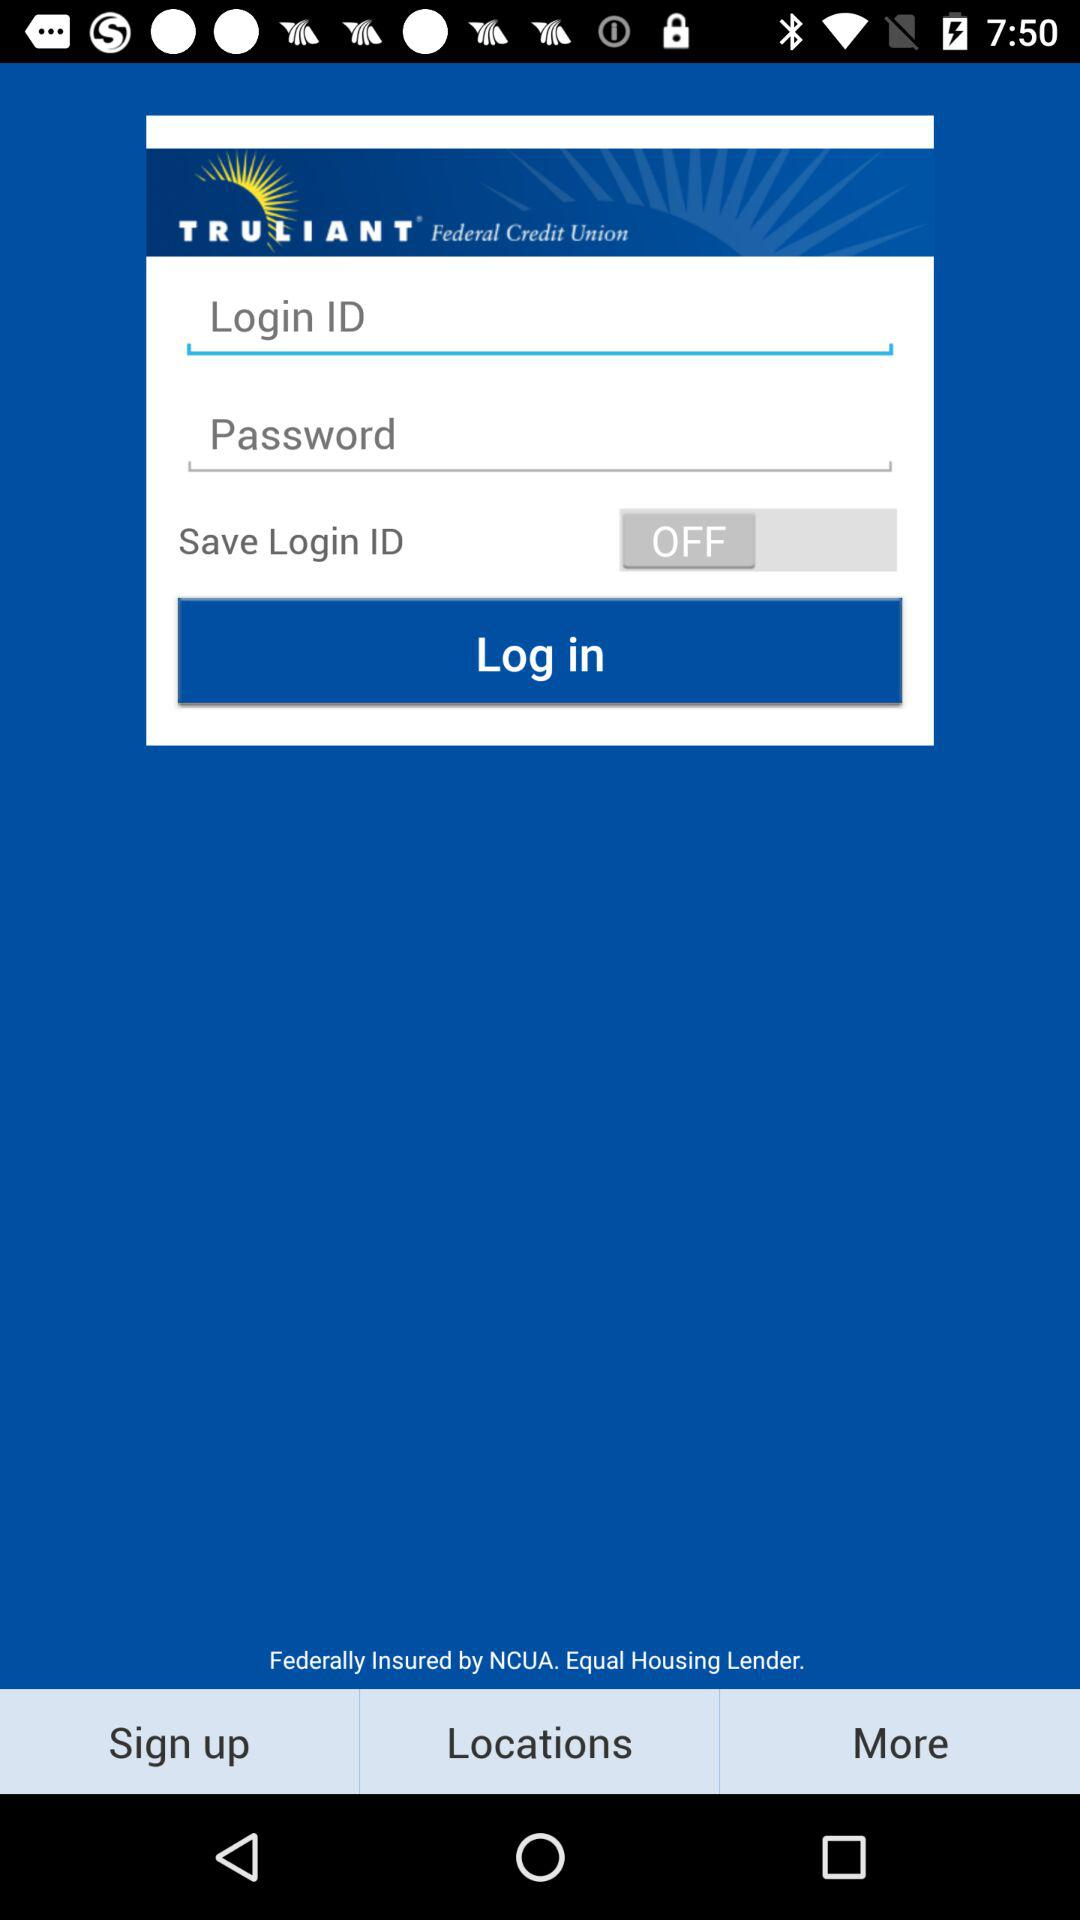What is the status of the "Save Login ID"? The status is "off". 